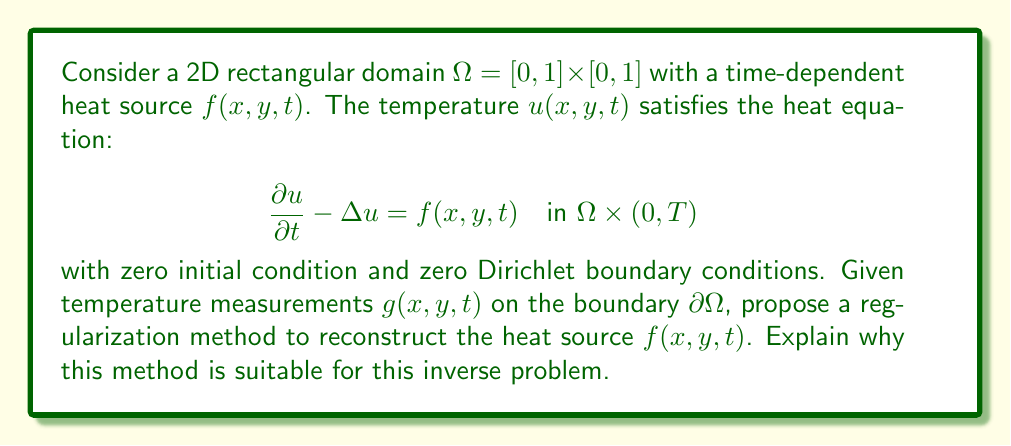What is the answer to this math problem? To reconstruct the time-dependent heat source $f(x,y,t)$ from boundary measurements, we can use Tikhonov regularization. This method is suitable for this inverse problem for the following reasons:

1. Ill-posedness: The inverse problem of reconstructing a heat source from boundary measurements is ill-posed, meaning small perturbations in the data can lead to large changes in the solution. Regularization helps stabilize the solution.

2. Formulation: We can formulate the problem as minimizing the functional:

   $$J(f) = \frac{1}{2}\int_0^T \int_{\partial\Omega} |u(f) - g|^2 d\sigma dt + \frac{\alpha}{2}\int_0^T \int_{\Omega} |f|^2 dxdydt$$

   where $u(f)$ is the solution of the forward problem with source $f$, $g$ is the measured data, and $\alpha > 0$ is the regularization parameter.

3. Regularization term: The second term $\frac{\alpha}{2}\int_0^T \int_{\Omega} |f|^2 dxdydt$ penalizes large values of $f$, promoting smoother solutions.

4. Optimization: We can use iterative methods (e.g., gradient descent) to minimize $J(f)$. The gradient of $J$ with respect to $f$ can be computed using the adjoint method.

5. Parameter selection: The regularization parameter $\alpha$ can be chosen using methods like the L-curve or generalized cross-validation to balance data fidelity and regularization.

6. Convergence: Under appropriate conditions, Tikhonov regularization converges to the true solution as the noise level in the data approaches zero and $\alpha$ is chosen optimally.

7. Flexibility: The method can be adapted to include prior information about the source by modifying the regularization term.

This approach provides a stable and computationally feasible method for reconstructing the time-dependent heat source from boundary measurements.
Answer: Tikhonov regularization with $J(f) = \frac{1}{2}\int_0^T \int_{\partial\Omega} |u(f) - g|^2 d\sigma dt + \frac{\alpha}{2}\int_0^T \int_{\Omega} |f|^2 dxdydt$ 